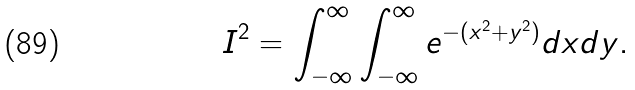<formula> <loc_0><loc_0><loc_500><loc_500>I ^ { 2 } = \int _ { - \infty } ^ { \infty } \int _ { - \infty } ^ { \infty } e ^ { - ( x ^ { 2 } + y ^ { 2 } ) } d x d y .</formula> 